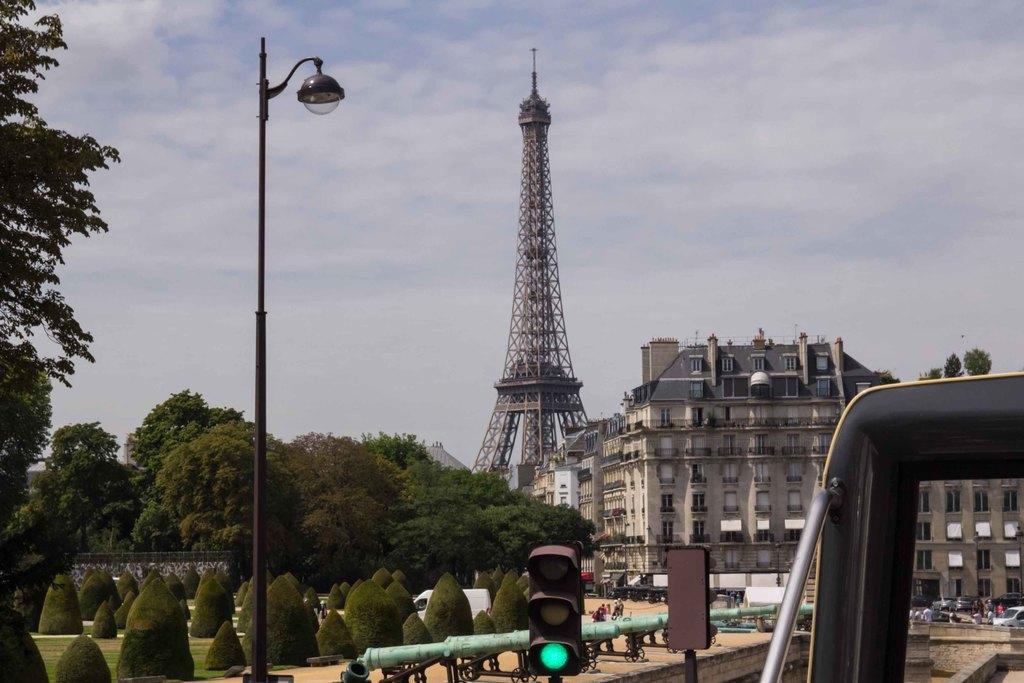Describe this image in one or two sentences. This image consists of trees and plants. To the right, there is a vehicle. In the background, there is a tower along with the buildings. At the bottom, there is signal pole. 